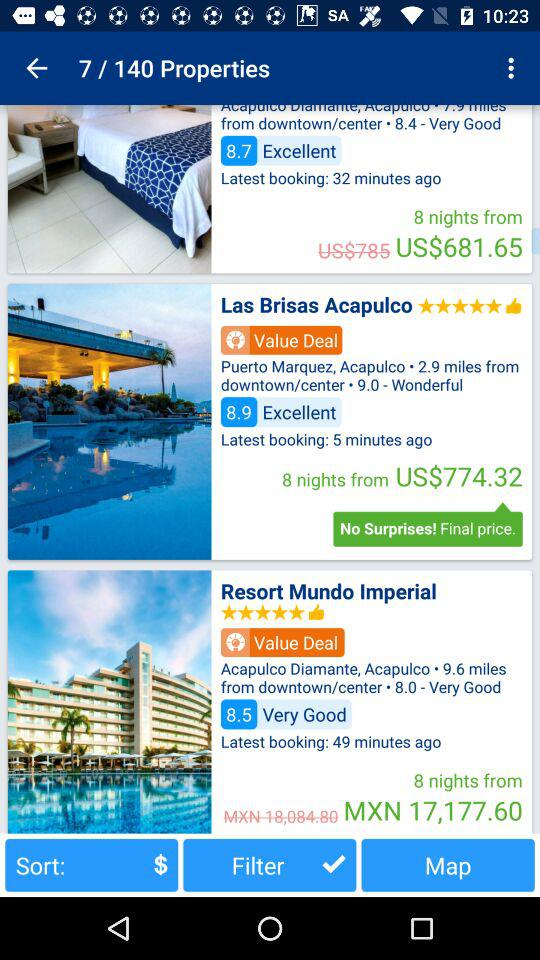What is the booking price for "Resort Mundo Imperial" after discount? The booking price for "Resort Mundo Imperial" after discount is 17,177.60 MXN. 